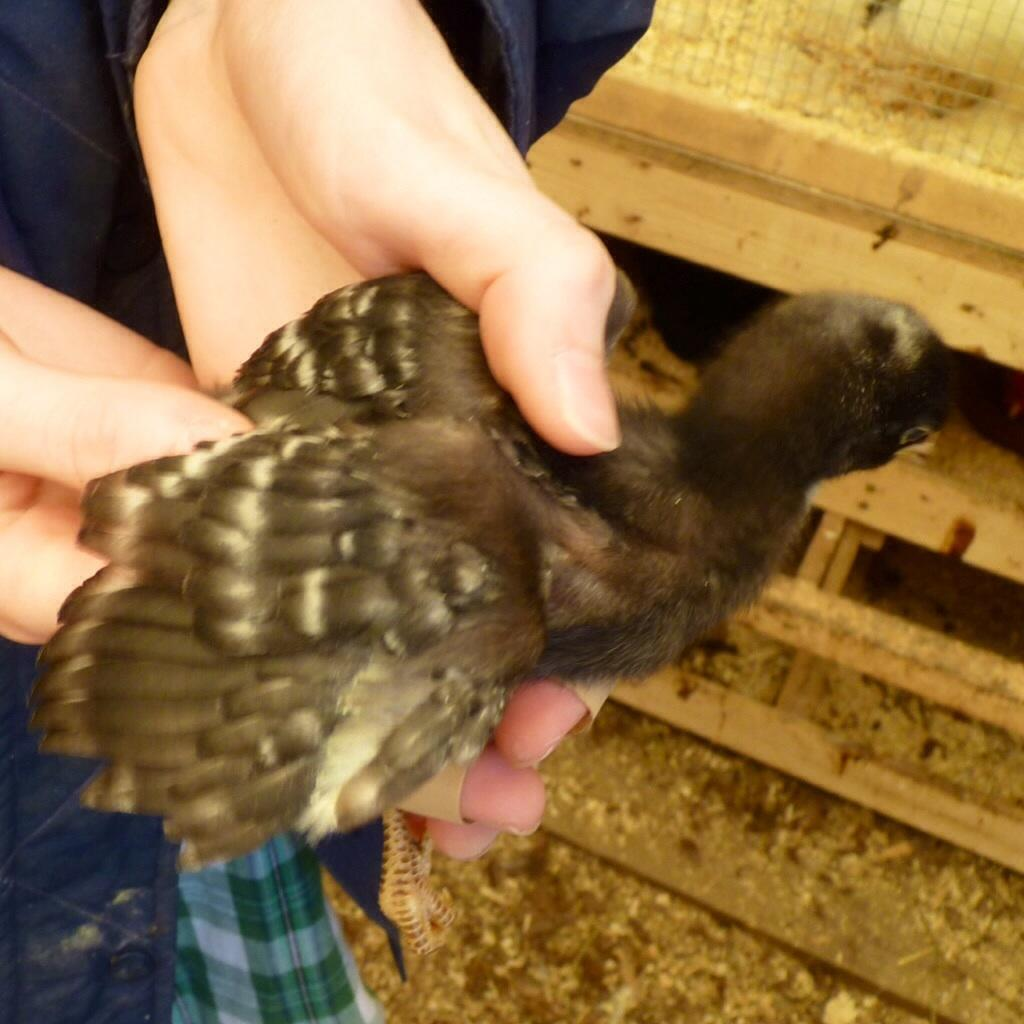What is the person holding in the image? There is a bird in a person's hands in the image. What type of object can be seen made of wood? There is a wooden object in the image. What material is used to create a barrier or fence in the image? Welded mesh wire is present in the image. What can be seen on the ground in the image? Dust is present on the ground in the image. What type of island is visible in the image? There is no island present in the image. What substance is being used to clean the wooden object in the image? There is no substance being used to clean the wooden object in the image; it is not mentioned in the provided facts. 